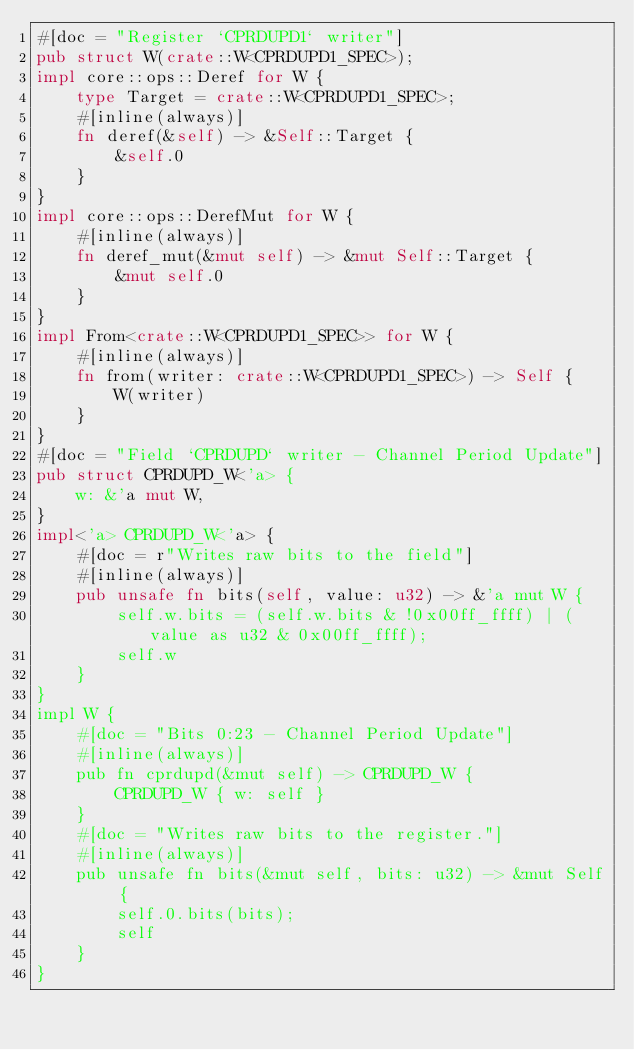<code> <loc_0><loc_0><loc_500><loc_500><_Rust_>#[doc = "Register `CPRDUPD1` writer"]
pub struct W(crate::W<CPRDUPD1_SPEC>);
impl core::ops::Deref for W {
    type Target = crate::W<CPRDUPD1_SPEC>;
    #[inline(always)]
    fn deref(&self) -> &Self::Target {
        &self.0
    }
}
impl core::ops::DerefMut for W {
    #[inline(always)]
    fn deref_mut(&mut self) -> &mut Self::Target {
        &mut self.0
    }
}
impl From<crate::W<CPRDUPD1_SPEC>> for W {
    #[inline(always)]
    fn from(writer: crate::W<CPRDUPD1_SPEC>) -> Self {
        W(writer)
    }
}
#[doc = "Field `CPRDUPD` writer - Channel Period Update"]
pub struct CPRDUPD_W<'a> {
    w: &'a mut W,
}
impl<'a> CPRDUPD_W<'a> {
    #[doc = r"Writes raw bits to the field"]
    #[inline(always)]
    pub unsafe fn bits(self, value: u32) -> &'a mut W {
        self.w.bits = (self.w.bits & !0x00ff_ffff) | (value as u32 & 0x00ff_ffff);
        self.w
    }
}
impl W {
    #[doc = "Bits 0:23 - Channel Period Update"]
    #[inline(always)]
    pub fn cprdupd(&mut self) -> CPRDUPD_W {
        CPRDUPD_W { w: self }
    }
    #[doc = "Writes raw bits to the register."]
    #[inline(always)]
    pub unsafe fn bits(&mut self, bits: u32) -> &mut Self {
        self.0.bits(bits);
        self
    }
}</code> 